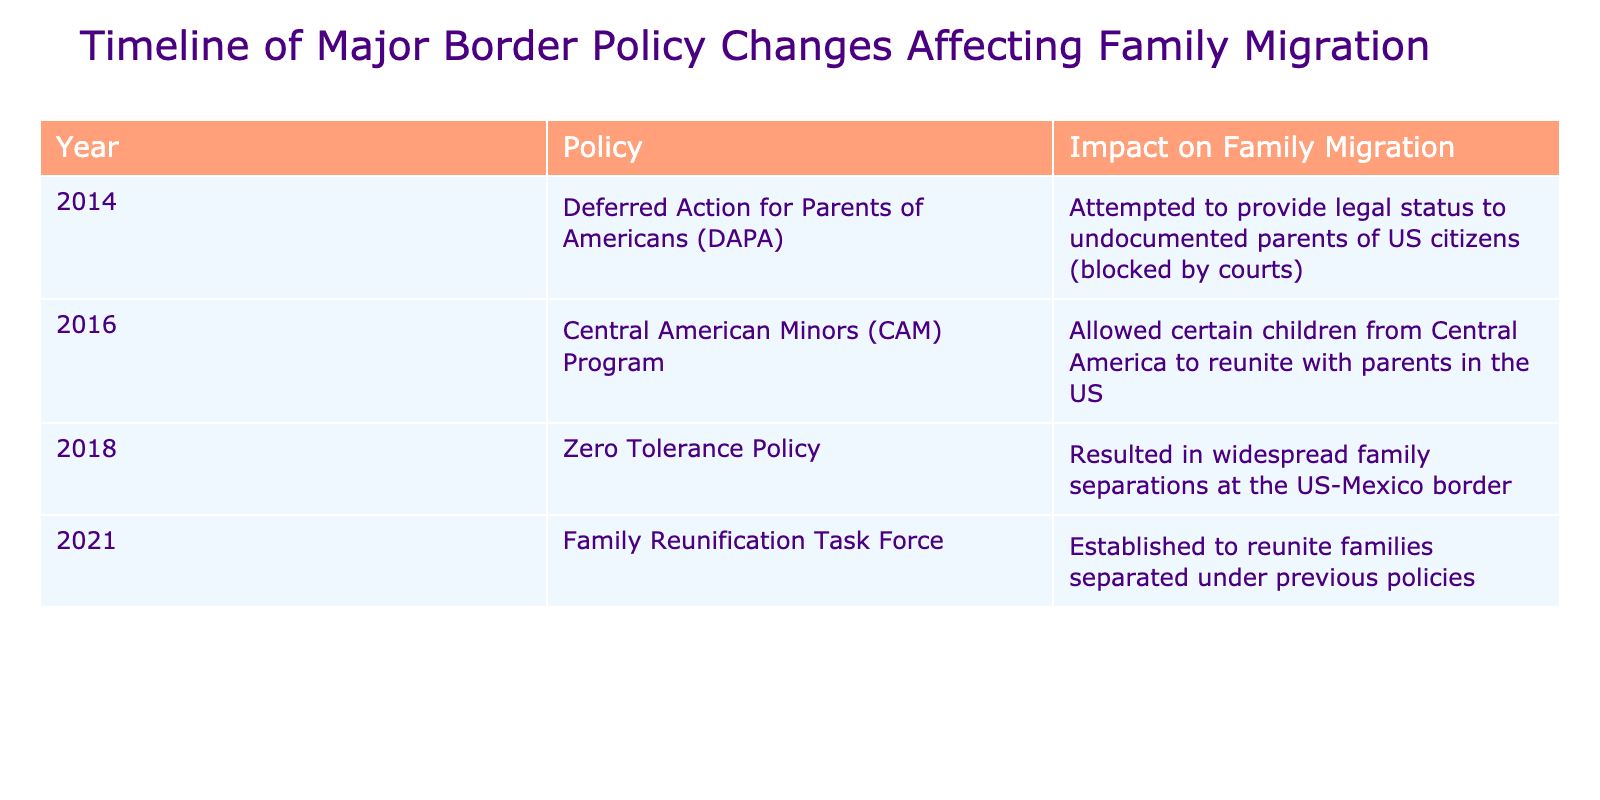What year did the Zero Tolerance Policy take effect? The table indicates that the Zero Tolerance Policy was instituted in the year 2018.
Answer: 2018 What was the impact of the Deferred Action for Parents of Americans (DAPA) on family migration? According to the table, DAPA attempted to provide legal status to undocumented parents of US citizens, but it was ultimately blocked by courts.
Answer: Attempted legal status, but blocked Did any policy in the table lead to family separations? The table lists the Zero Tolerance Policy, which resulted in widespread family separations at the US-Mexico border, confirming that yes, this policy did lead to separations.
Answer: Yes Which policy was established in 2021 and what was its purpose? The Family Reunification Task Force was established in 2021, and its purpose was to reunite families that were separated under previous policies.
Answer: Family Reunification Task Force; reunite separated families What is the difference in impact on family migration between the Central American Minors (CAM) Program and the Zero Tolerance Policy? The CAM Program allowed certain children from Central America to reunite with parents in the US, while the Zero Tolerance Policy led to widespread family separations. This indicates a positive versus negative impact on family migration.
Answer: CAM: positive, Zero Tolerance: negative How many distinct policies concerning family migration are listed in the table? By counting the entries in the table, there are a total of four distinct policies mentioned.
Answer: 4 Which policy aimed to reunite families after separations? The Family Reunification Task Force, established in 2021, is explicitly stated in the table as having the aim of reuniting families separated by previous policies.
Answer: Family Reunification Task Force If we consider all the policies listed, how many of them had a direct negative effect on family migration? Both the Zero Tolerance Policy and the blocked DAPA had direct negative effects, resulting in family separations and a lack of legal status. That sums to two policies with negative effects.
Answer: 2 What can be inferred about the evolution of border policies regarding family migration from 2014 to 2021 based on the table? From 2014 to 2021, the policies show a shift from attempts to provide legal status (DAPA) to harmful separations (Zero Tolerance Policy) followed by efforts to reunite families (Family Reunification Task Force), indicating a dynamic and changing approach to family migration.
Answer: Shift from legal status attempts to harmful separation, then reunification efforts 